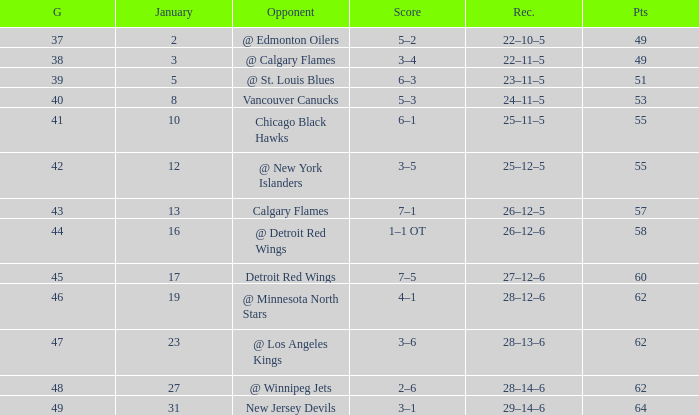Which Points have a Score of 4–1? 62.0. 